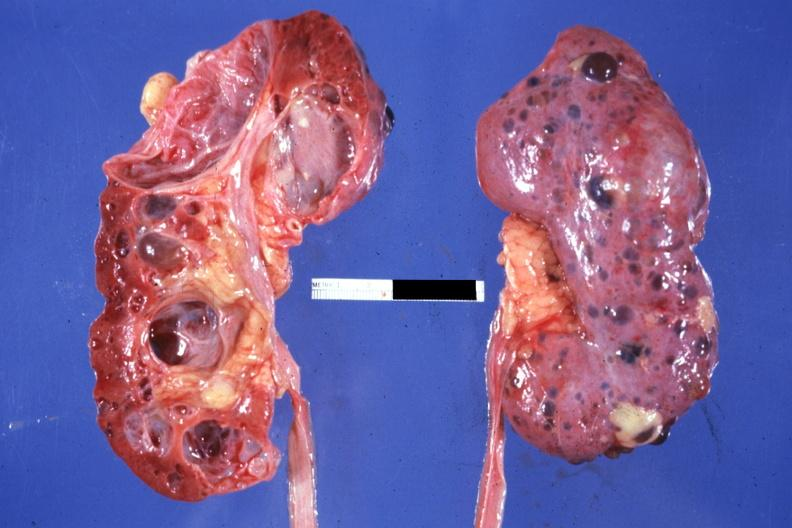does this image show nice photo one kidney opened the other from capsular surface many cysts?
Answer the question using a single word or phrase. Yes 